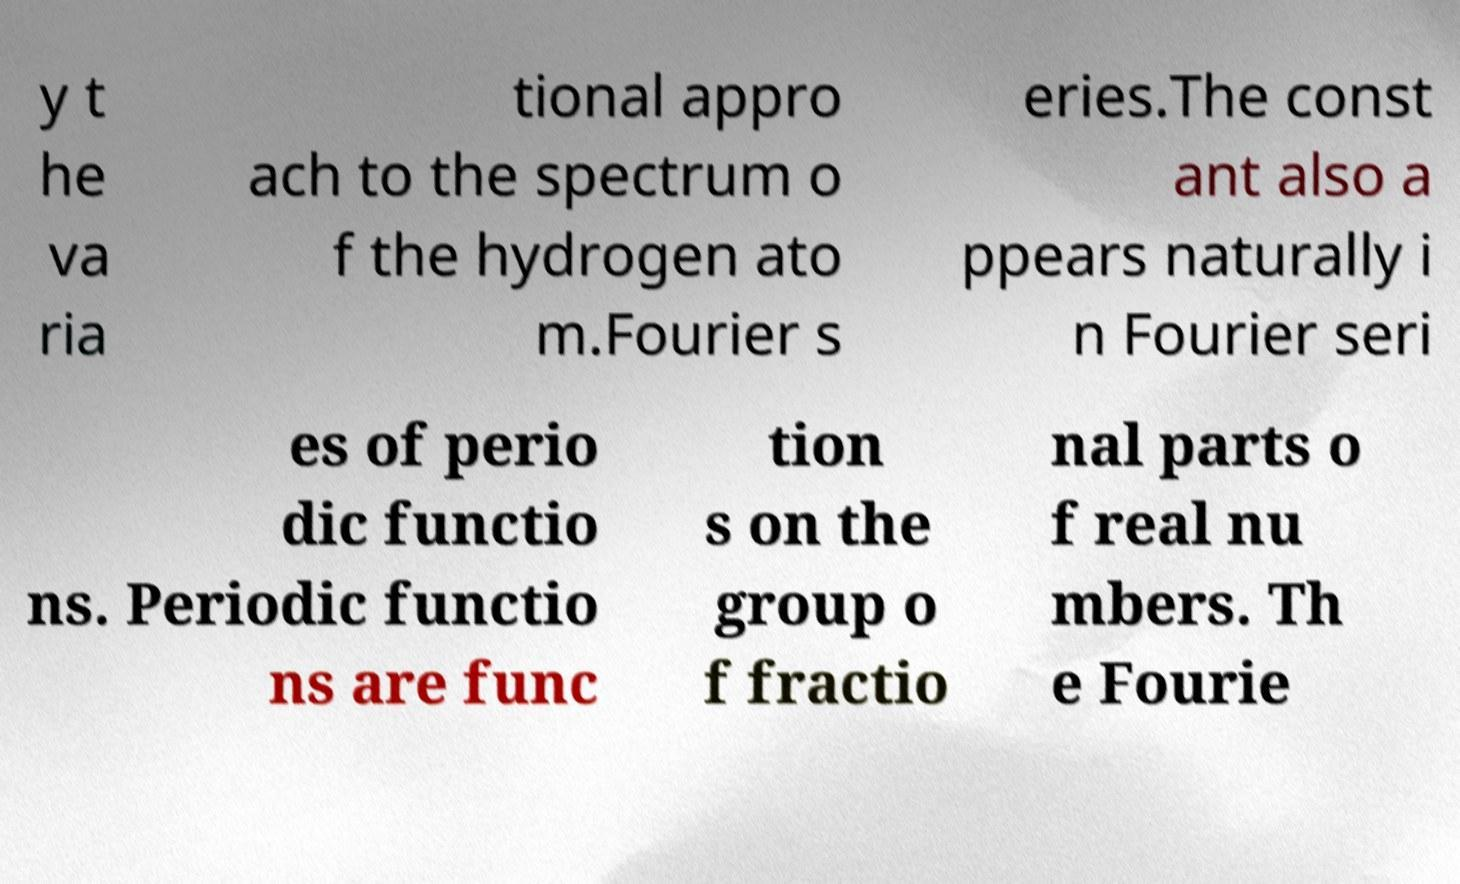Could you assist in decoding the text presented in this image and type it out clearly? y t he va ria tional appro ach to the spectrum o f the hydrogen ato m.Fourier s eries.The const ant also a ppears naturally i n Fourier seri es of perio dic functio ns. Periodic functio ns are func tion s on the group o f fractio nal parts o f real nu mbers. Th e Fourie 